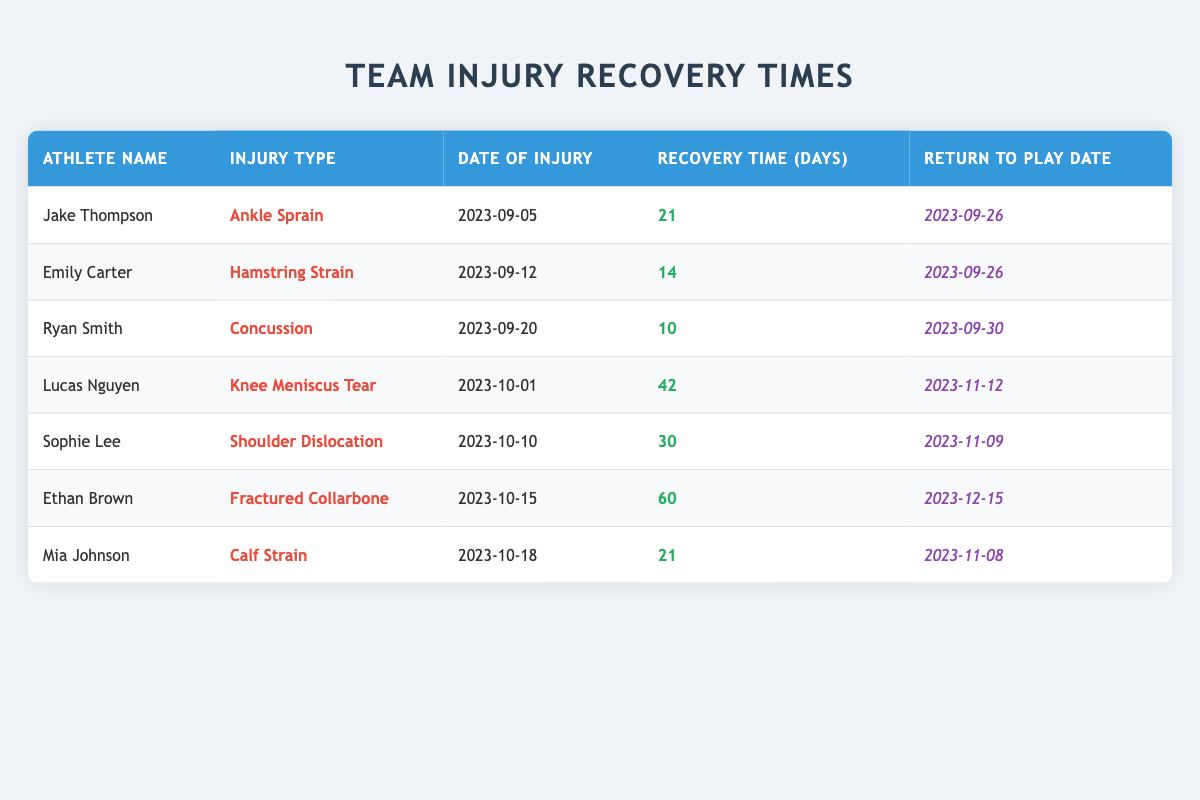What is the recovery time for Emily Carter? Emily Carter's injury is listed as a Hamstring Strain and her recovery time in the table is specified as 14 days.
Answer: 14 days Which athlete has the longest recovery time? Scanning through the recovery times listed in the table, Ethan Brown has a recovery time of 60 days, which is longer than any other athlete's recovery time.
Answer: Ethan Brown What injury did Lucas Nguyen suffer? According to the table, Lucas Nguyen's injury type is listed as a Knee Meniscus Tear.
Answer: Knee Meniscus Tear Is it true that Ryan Smith returned to play before Emily Carter? Looking at the return to play dates, Ryan Smith's return date is September 30, while Emily Carter's return date is September 26. Since September 30 is after September 26, Ryan Smith did not return before Emily Carter.
Answer: No What is the average recovery time for all athletes listed in the table? To find the average recovery time, sum the recovery times: (21 + 14 + 10 + 42 + 30 + 60 + 21) = 208 days. There are 7 athletes, so the average recovery time is 208/7 ≈ 29.71 days, which can be rounded to approximately 30 days.
Answer: Approximately 30 days How many athletes returned to play on the same date? Analyzing the return to play dates, both Jake Thompson and Emily Carter returned on September 26, which means 2 athletes returned on the same date.
Answer: 2 athletes What injury requires the second longest recovery time? Reviewing the recovery times in descending order, Lucas Nguyen's Knee Meniscus Tear has the longest recovery time of 42 days, and Sophie Lee's Shoulder Dislocation has the second longest recovery time of 30 days.
Answer: Shoulder Dislocation Who sustained an injury the earliest, and what was it? Jake Thompson sustained an Ankle Sprain injury on September 5, which is the earliest date of injury listed in the table.
Answer: Ankle Sprain by Jake Thompson 